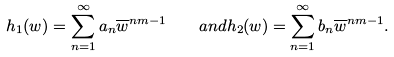<formula> <loc_0><loc_0><loc_500><loc_500>h _ { 1 } ( w ) = \sum _ { n = 1 } ^ { \infty } a _ { n } \overline { w } ^ { n m - 1 } \quad a n d h _ { 2 } ( w ) = \sum _ { n = 1 } ^ { \infty } b _ { n } \overline { w } ^ { n m - 1 } .</formula> 